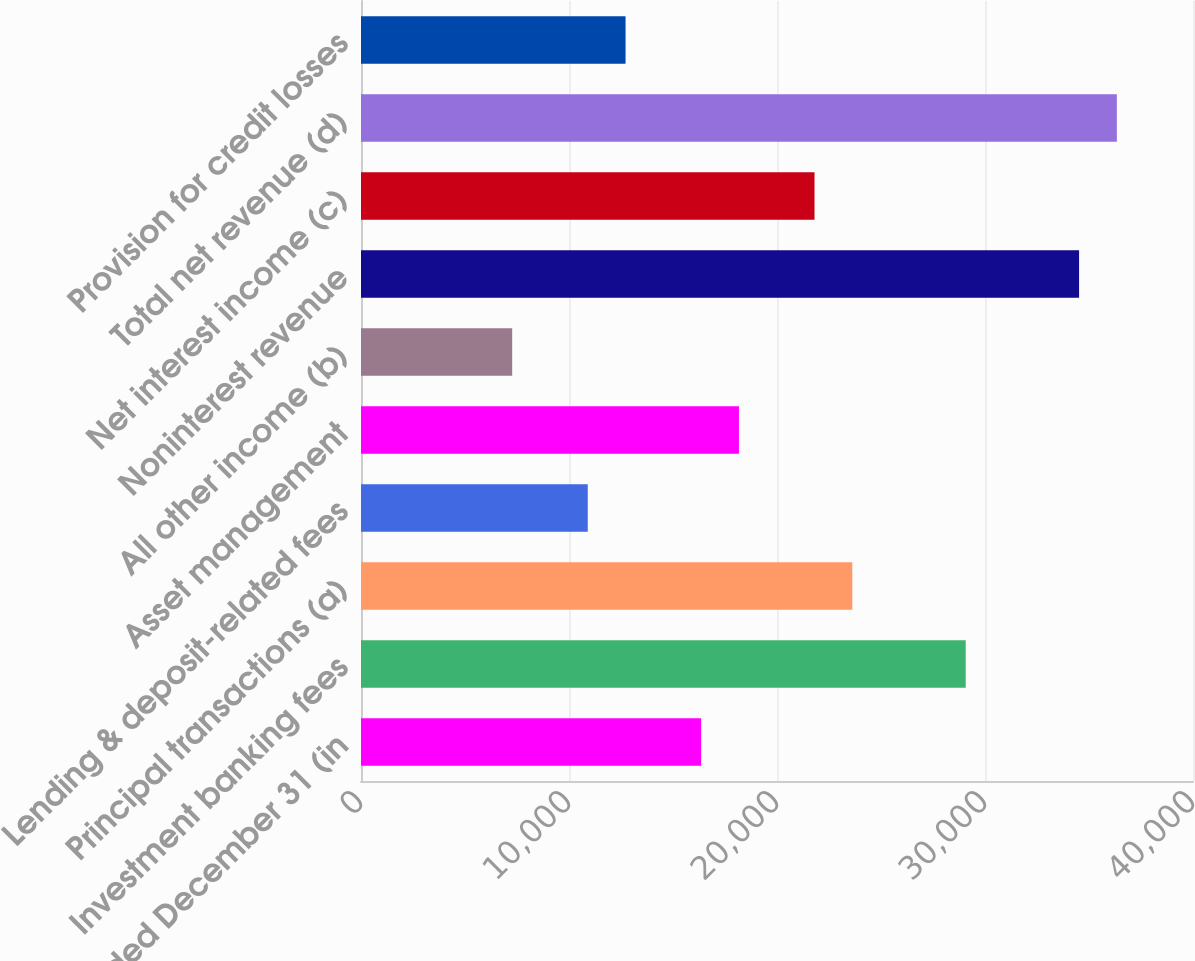<chart> <loc_0><loc_0><loc_500><loc_500><bar_chart><fcel>Year ended December 31 (in<fcel>Investment banking fees<fcel>Principal transactions (a)<fcel>Lending & deposit-related fees<fcel>Asset management<fcel>All other income (b)<fcel>Noninterest revenue<fcel>Net interest income (c)<fcel>Total net revenue (d)<fcel>Provision for credit losses<nl><fcel>16353<fcel>29071.8<fcel>23620.9<fcel>10902.2<fcel>18170<fcel>7268.27<fcel>34522.6<fcel>21803.9<fcel>36339.6<fcel>12719.1<nl></chart> 